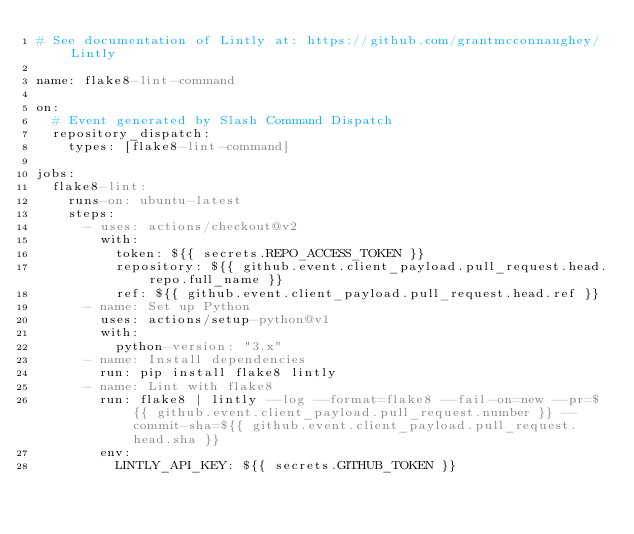Convert code to text. <code><loc_0><loc_0><loc_500><loc_500><_YAML_># See documentation of Lintly at: https://github.com/grantmcconnaughey/Lintly

name: flake8-lint-command

on:
  # Event generated by Slash Command Dispatch
  repository_dispatch:
    types: [flake8-lint-command]

jobs:
  flake8-lint:
    runs-on: ubuntu-latest
    steps:
      - uses: actions/checkout@v2
        with:
          token: ${{ secrets.REPO_ACCESS_TOKEN }}
          repository: ${{ github.event.client_payload.pull_request.head.repo.full_name }}
          ref: ${{ github.event.client_payload.pull_request.head.ref }}
      - name: Set up Python
        uses: actions/setup-python@v1
        with:
          python-version: "3.x"
      - name: Install dependencies
        run: pip install flake8 lintly
      - name: Lint with flake8
        run: flake8 | lintly --log --format=flake8 --fail-on=new --pr=${{ github.event.client_payload.pull_request.number }} --commit-sha=${{ github.event.client_payload.pull_request.head.sha }}
        env:
          LINTLY_API_KEY: ${{ secrets.GITHUB_TOKEN }}
</code> 